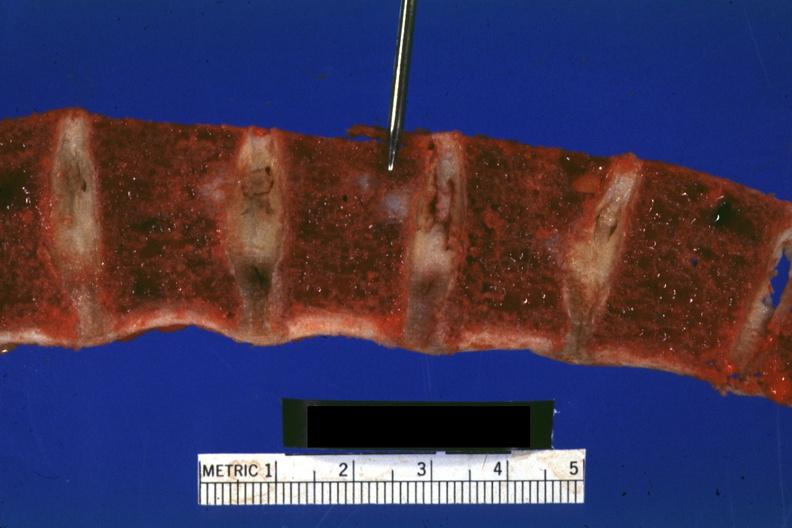how does this image show vertebral bodies?
Answer the question using a single word or phrase. With typical gelatinous-hemorrhagic lesions 